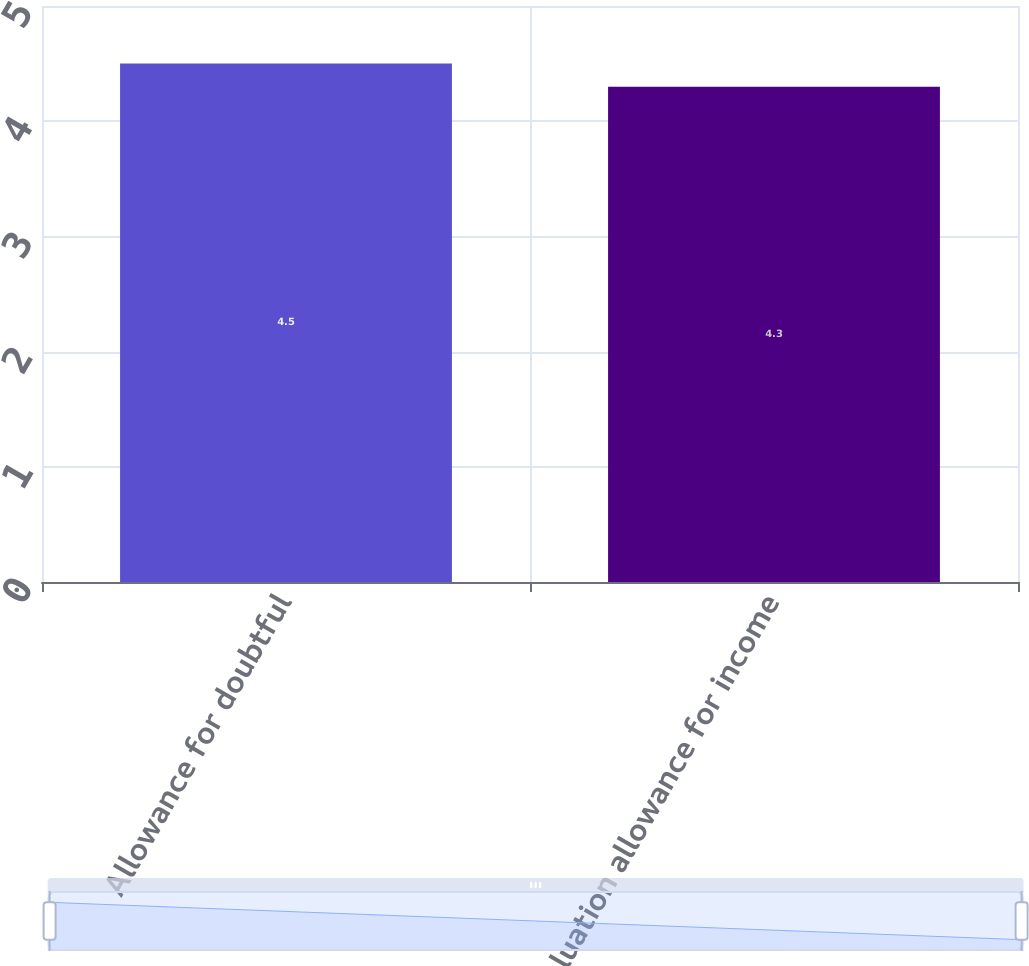Convert chart to OTSL. <chart><loc_0><loc_0><loc_500><loc_500><bar_chart><fcel>Allowance for doubtful<fcel>Valuation allowance for income<nl><fcel>4.5<fcel>4.3<nl></chart> 